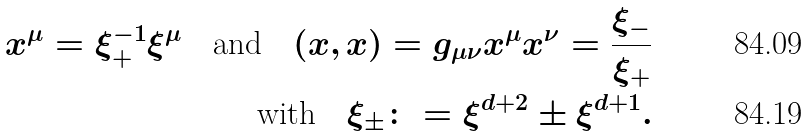<formula> <loc_0><loc_0><loc_500><loc_500>x ^ { \mu } = \xi _ { + } ^ { - 1 } \xi ^ { \mu } \quad \text {and} \quad ( x , x ) = g _ { \mu \nu } x ^ { \mu } x ^ { \nu } = \frac { \xi _ { - } } { \xi _ { + } } \\ \text {with} \quad \xi _ { \pm } \colon = \xi ^ { d + 2 } \pm \xi ^ { d + 1 } .</formula> 